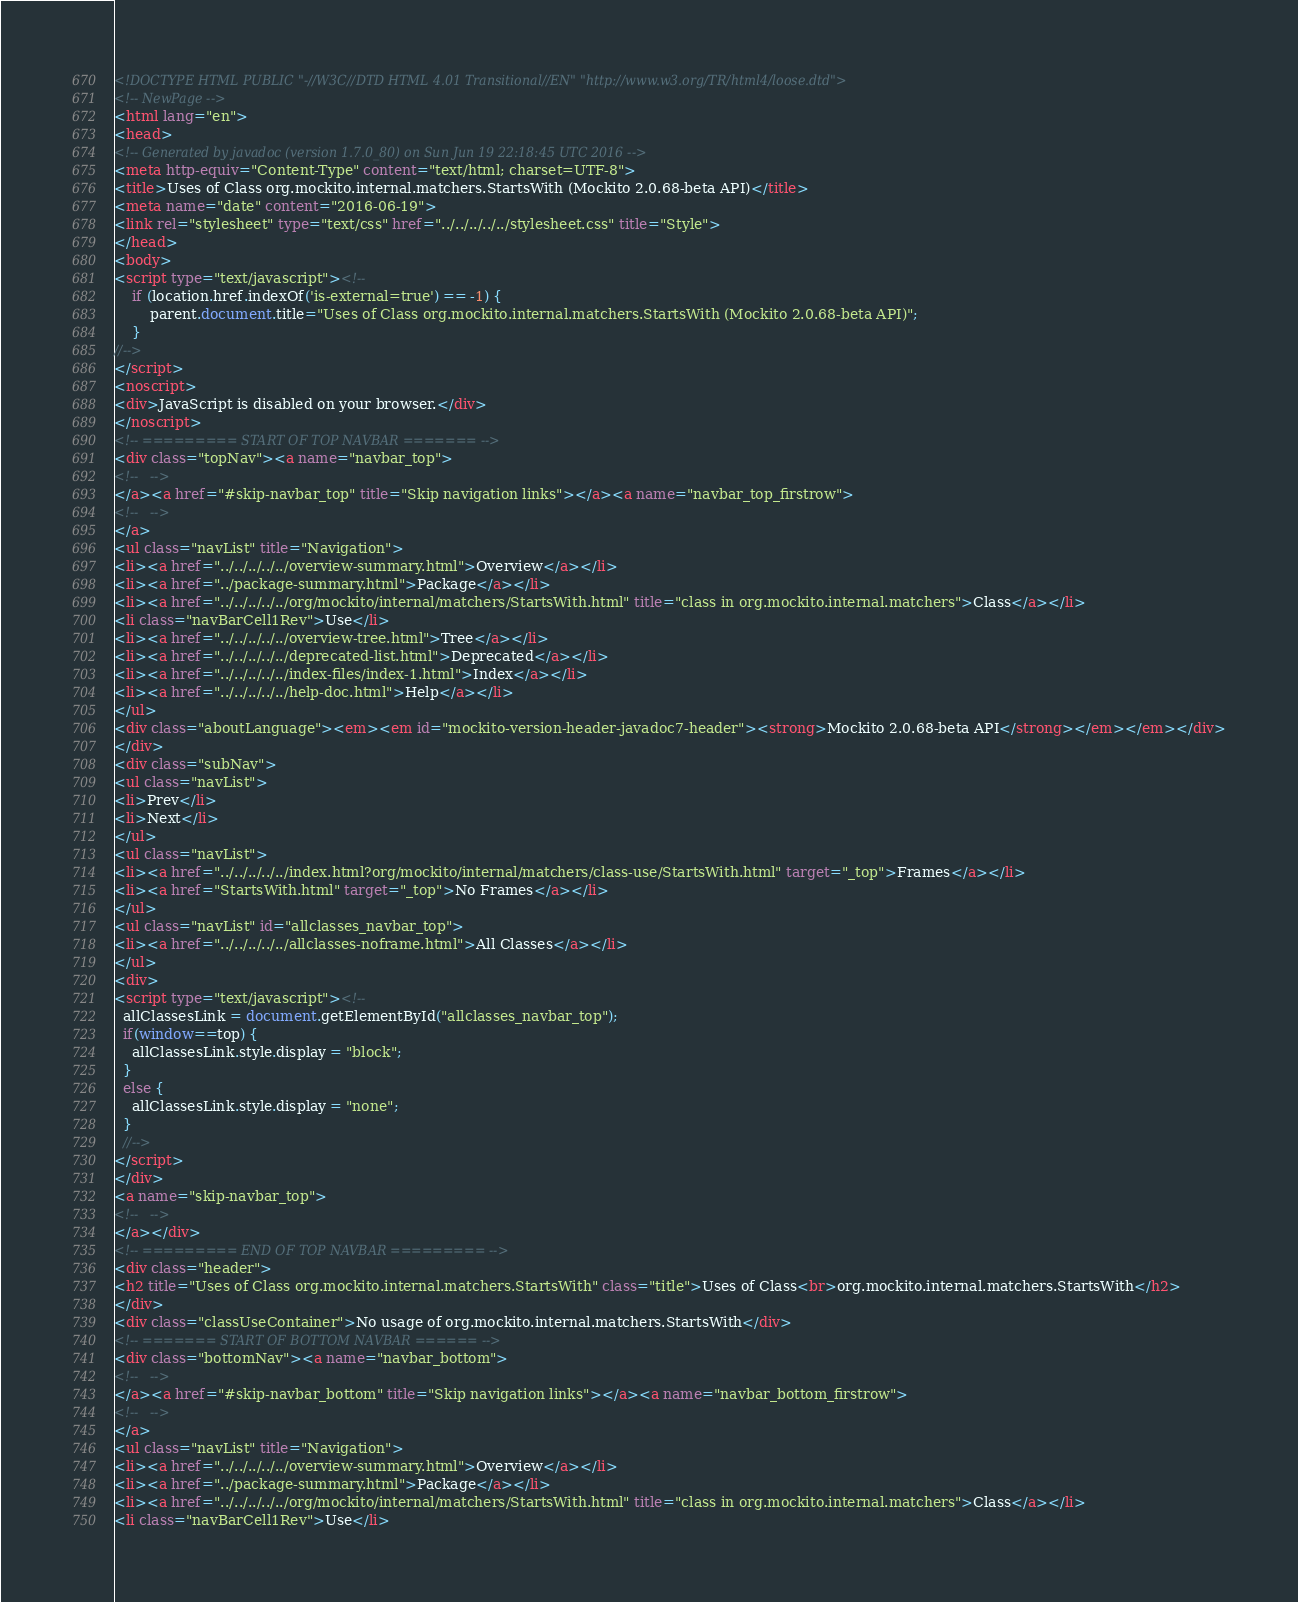Convert code to text. <code><loc_0><loc_0><loc_500><loc_500><_HTML_><!DOCTYPE HTML PUBLIC "-//W3C//DTD HTML 4.01 Transitional//EN" "http://www.w3.org/TR/html4/loose.dtd">
<!-- NewPage -->
<html lang="en">
<head>
<!-- Generated by javadoc (version 1.7.0_80) on Sun Jun 19 22:18:45 UTC 2016 -->
<meta http-equiv="Content-Type" content="text/html; charset=UTF-8">
<title>Uses of Class org.mockito.internal.matchers.StartsWith (Mockito 2.0.68-beta API)</title>
<meta name="date" content="2016-06-19">
<link rel="stylesheet" type="text/css" href="../../../../../stylesheet.css" title="Style">
</head>
<body>
<script type="text/javascript"><!--
    if (location.href.indexOf('is-external=true') == -1) {
        parent.document.title="Uses of Class org.mockito.internal.matchers.StartsWith (Mockito 2.0.68-beta API)";
    }
//-->
</script>
<noscript>
<div>JavaScript is disabled on your browser.</div>
</noscript>
<!-- ========= START OF TOP NAVBAR ======= -->
<div class="topNav"><a name="navbar_top">
<!--   -->
</a><a href="#skip-navbar_top" title="Skip navigation links"></a><a name="navbar_top_firstrow">
<!--   -->
</a>
<ul class="navList" title="Navigation">
<li><a href="../../../../../overview-summary.html">Overview</a></li>
<li><a href="../package-summary.html">Package</a></li>
<li><a href="../../../../../org/mockito/internal/matchers/StartsWith.html" title="class in org.mockito.internal.matchers">Class</a></li>
<li class="navBarCell1Rev">Use</li>
<li><a href="../../../../../overview-tree.html">Tree</a></li>
<li><a href="../../../../../deprecated-list.html">Deprecated</a></li>
<li><a href="../../../../../index-files/index-1.html">Index</a></li>
<li><a href="../../../../../help-doc.html">Help</a></li>
</ul>
<div class="aboutLanguage"><em><em id="mockito-version-header-javadoc7-header"><strong>Mockito 2.0.68-beta API</strong></em></em></div>
</div>
<div class="subNav">
<ul class="navList">
<li>Prev</li>
<li>Next</li>
</ul>
<ul class="navList">
<li><a href="../../../../../index.html?org/mockito/internal/matchers/class-use/StartsWith.html" target="_top">Frames</a></li>
<li><a href="StartsWith.html" target="_top">No Frames</a></li>
</ul>
<ul class="navList" id="allclasses_navbar_top">
<li><a href="../../../../../allclasses-noframe.html">All Classes</a></li>
</ul>
<div>
<script type="text/javascript"><!--
  allClassesLink = document.getElementById("allclasses_navbar_top");
  if(window==top) {
    allClassesLink.style.display = "block";
  }
  else {
    allClassesLink.style.display = "none";
  }
  //-->
</script>
</div>
<a name="skip-navbar_top">
<!--   -->
</a></div>
<!-- ========= END OF TOP NAVBAR ========= -->
<div class="header">
<h2 title="Uses of Class org.mockito.internal.matchers.StartsWith" class="title">Uses of Class<br>org.mockito.internal.matchers.StartsWith</h2>
</div>
<div class="classUseContainer">No usage of org.mockito.internal.matchers.StartsWith</div>
<!-- ======= START OF BOTTOM NAVBAR ====== -->
<div class="bottomNav"><a name="navbar_bottom">
<!--   -->
</a><a href="#skip-navbar_bottom" title="Skip navigation links"></a><a name="navbar_bottom_firstrow">
<!--   -->
</a>
<ul class="navList" title="Navigation">
<li><a href="../../../../../overview-summary.html">Overview</a></li>
<li><a href="../package-summary.html">Package</a></li>
<li><a href="../../../../../org/mockito/internal/matchers/StartsWith.html" title="class in org.mockito.internal.matchers">Class</a></li>
<li class="navBarCell1Rev">Use</li></code> 